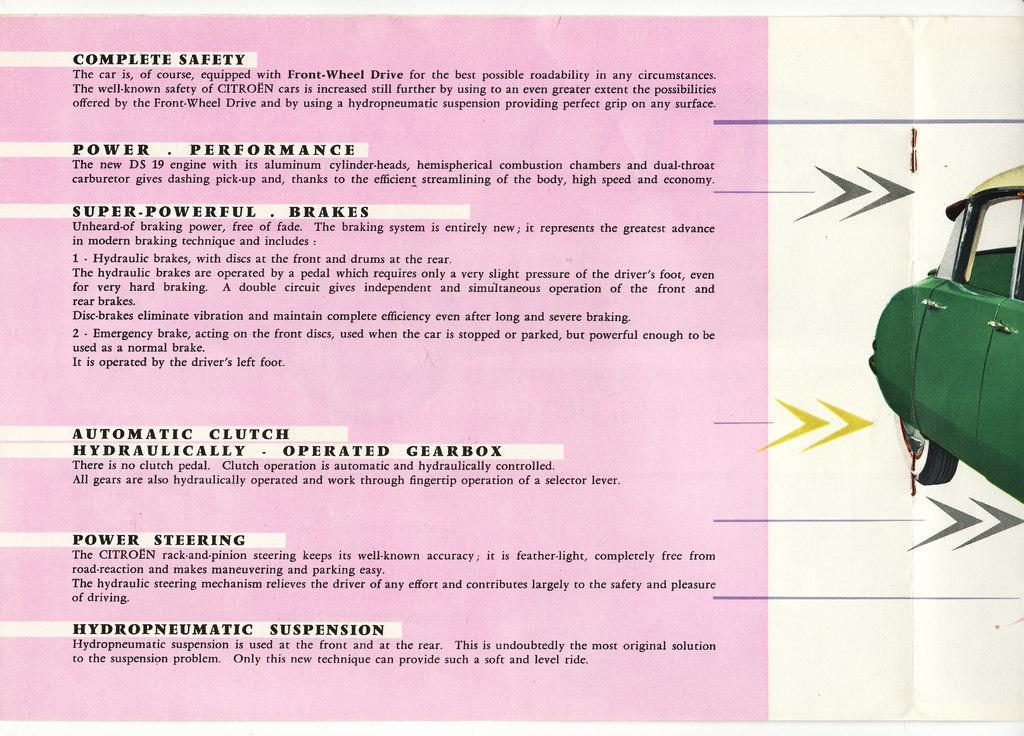Describe this image in one or two sentences. This picture shows paper cutting. We see text on the left and a car picture on the right. 